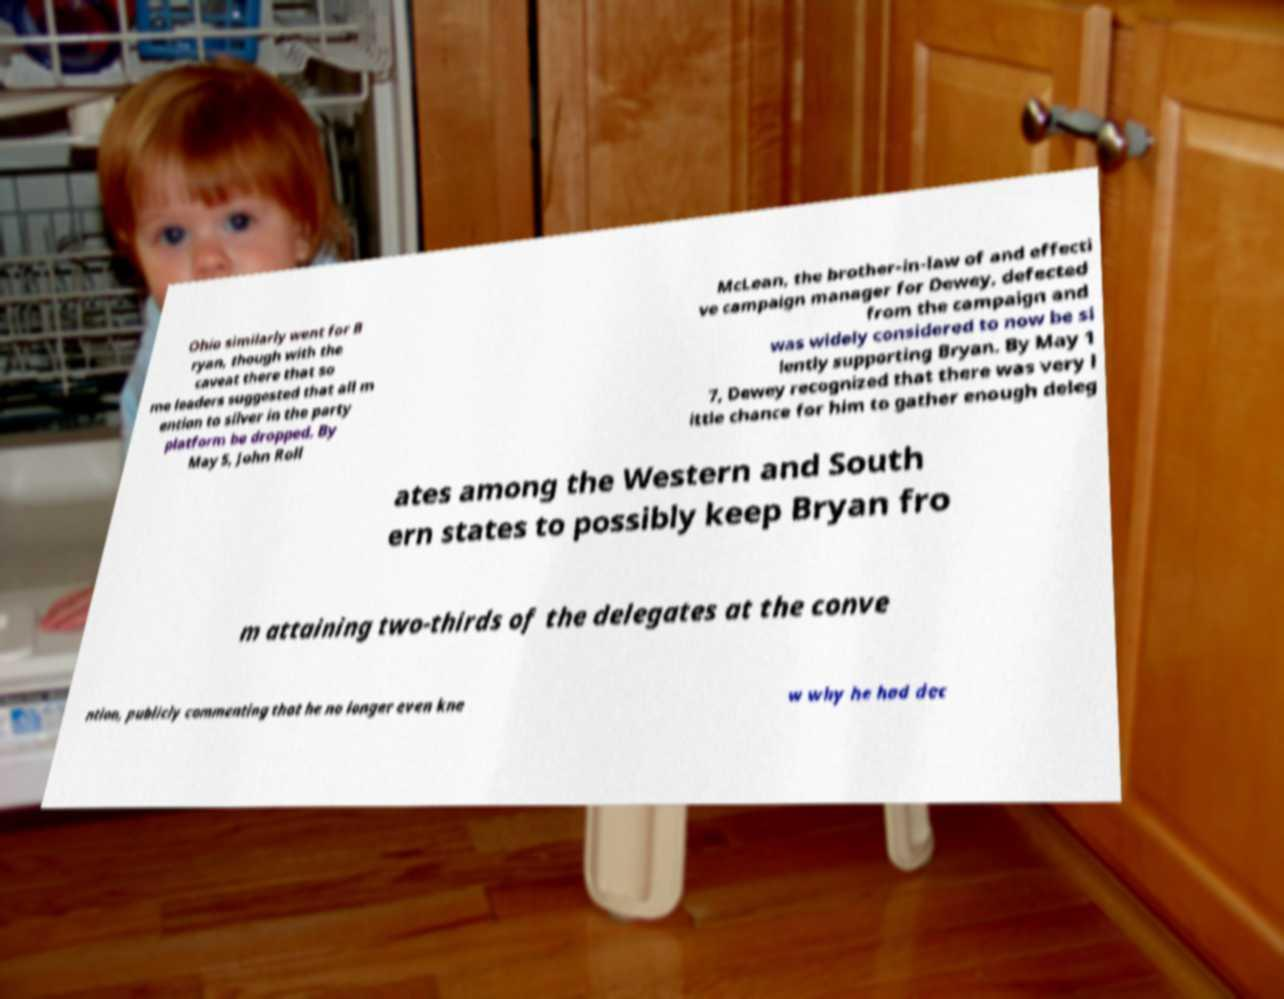Could you assist in decoding the text presented in this image and type it out clearly? Ohio similarly went for B ryan, though with the caveat there that so me leaders suggested that all m ention to silver in the party platform be dropped. By May 5, John Roll McLean, the brother-in-law of and effecti ve campaign manager for Dewey, defected from the campaign and was widely considered to now be si lently supporting Bryan. By May 1 7, Dewey recognized that there was very l ittle chance for him to gather enough deleg ates among the Western and South ern states to possibly keep Bryan fro m attaining two-thirds of the delegates at the conve ntion, publicly commenting that he no longer even kne w why he had dec 